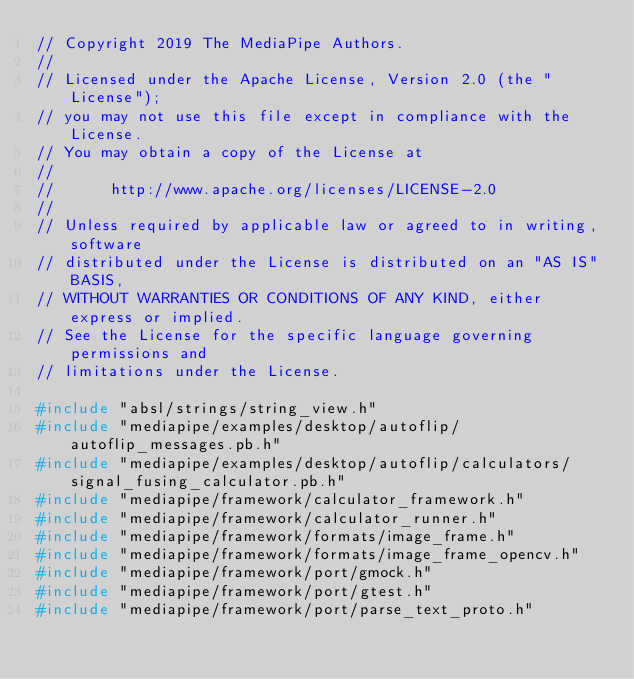Convert code to text. <code><loc_0><loc_0><loc_500><loc_500><_C++_>// Copyright 2019 The MediaPipe Authors.
//
// Licensed under the Apache License, Version 2.0 (the "License");
// you may not use this file except in compliance with the License.
// You may obtain a copy of the License at
//
//      http://www.apache.org/licenses/LICENSE-2.0
//
// Unless required by applicable law or agreed to in writing, software
// distributed under the License is distributed on an "AS IS" BASIS,
// WITHOUT WARRANTIES OR CONDITIONS OF ANY KIND, either express or implied.
// See the License for the specific language governing permissions and
// limitations under the License.

#include "absl/strings/string_view.h"
#include "mediapipe/examples/desktop/autoflip/autoflip_messages.pb.h"
#include "mediapipe/examples/desktop/autoflip/calculators/signal_fusing_calculator.pb.h"
#include "mediapipe/framework/calculator_framework.h"
#include "mediapipe/framework/calculator_runner.h"
#include "mediapipe/framework/formats/image_frame.h"
#include "mediapipe/framework/formats/image_frame_opencv.h"
#include "mediapipe/framework/port/gmock.h"
#include "mediapipe/framework/port/gtest.h"
#include "mediapipe/framework/port/parse_text_proto.h"</code> 